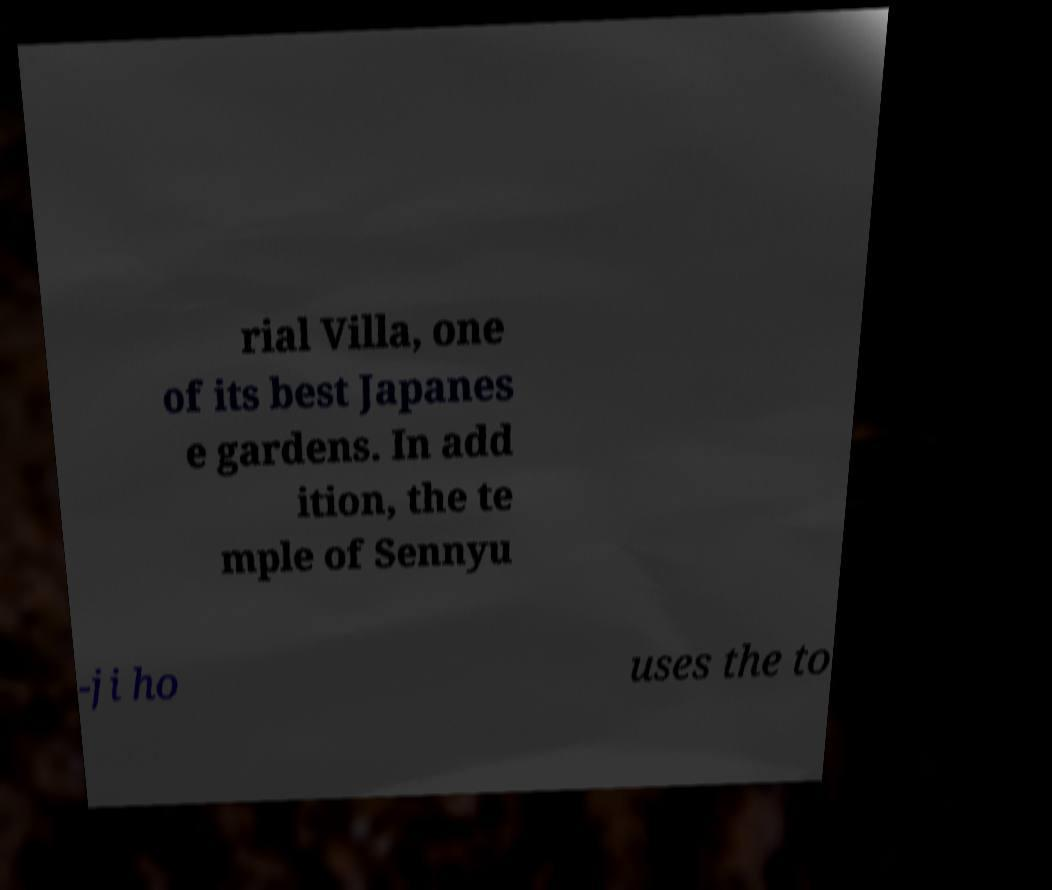Could you extract and type out the text from this image? rial Villa, one of its best Japanes e gardens. In add ition, the te mple of Sennyu -ji ho uses the to 